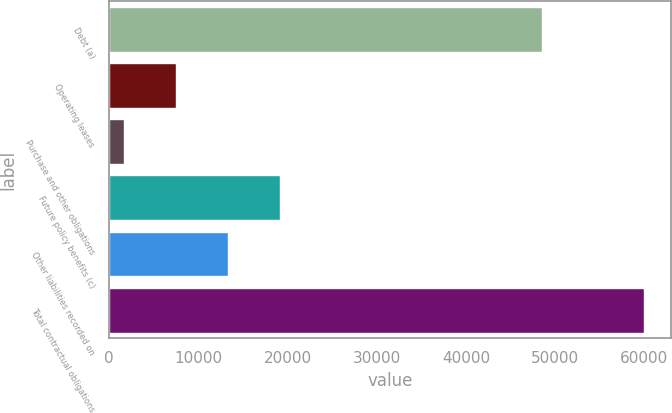Convert chart. <chart><loc_0><loc_0><loc_500><loc_500><bar_chart><fcel>Debt (a)<fcel>Operating leases<fcel>Purchase and other obligations<fcel>Future policy benefits (c)<fcel>Other liabilities recorded on<fcel>Total contractual obligations<nl><fcel>48502<fcel>7538<fcel>1707<fcel>19200<fcel>13369<fcel>60017<nl></chart> 